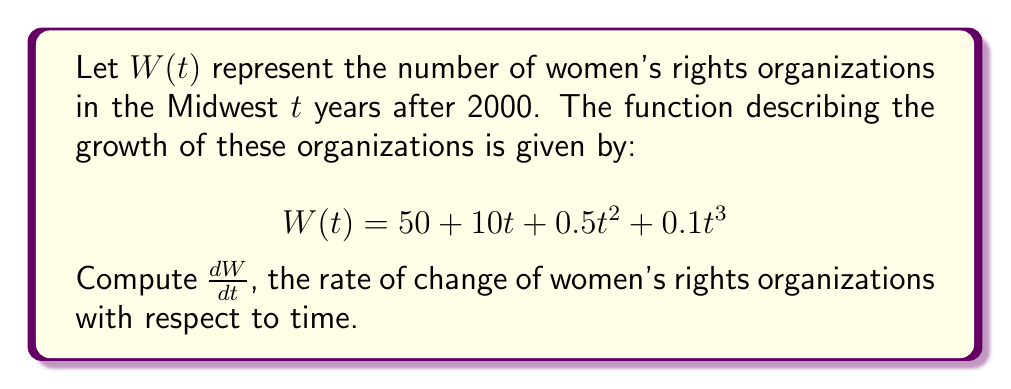Could you help me with this problem? To find the derivative of $W(t)$ with respect to $t$, we need to apply the power rule and the constant rule of differentiation.

1) The constant term 50:
   The derivative of a constant is 0.
   $\frac{d}{dt}(50) = 0$

2) The linear term $10t$:
   The derivative of $at$ is $a$.
   $\frac{d}{dt}(10t) = 10$

3) The quadratic term $0.5t^2$:
   The power rule states that the derivative of $at^n$ is $nat^{n-1}$.
   $\frac{d}{dt}(0.5t^2) = 2 \cdot 0.5t^{2-1} = t$

4) The cubic term $0.1t^3$:
   Again, applying the power rule:
   $\frac{d}{dt}(0.1t^3) = 3 \cdot 0.1t^{3-1} = 0.3t^2$

Now, we sum all these terms to get the final derivative:

$$\frac{dW}{dt} = 0 + 10 + t + 0.3t^2$$

This can be simplified to:

$$\frac{dW}{dt} = 10 + t + 0.3t^2$$
Answer: $$\frac{dW}{dt} = 10 + t + 0.3t^2$$ 